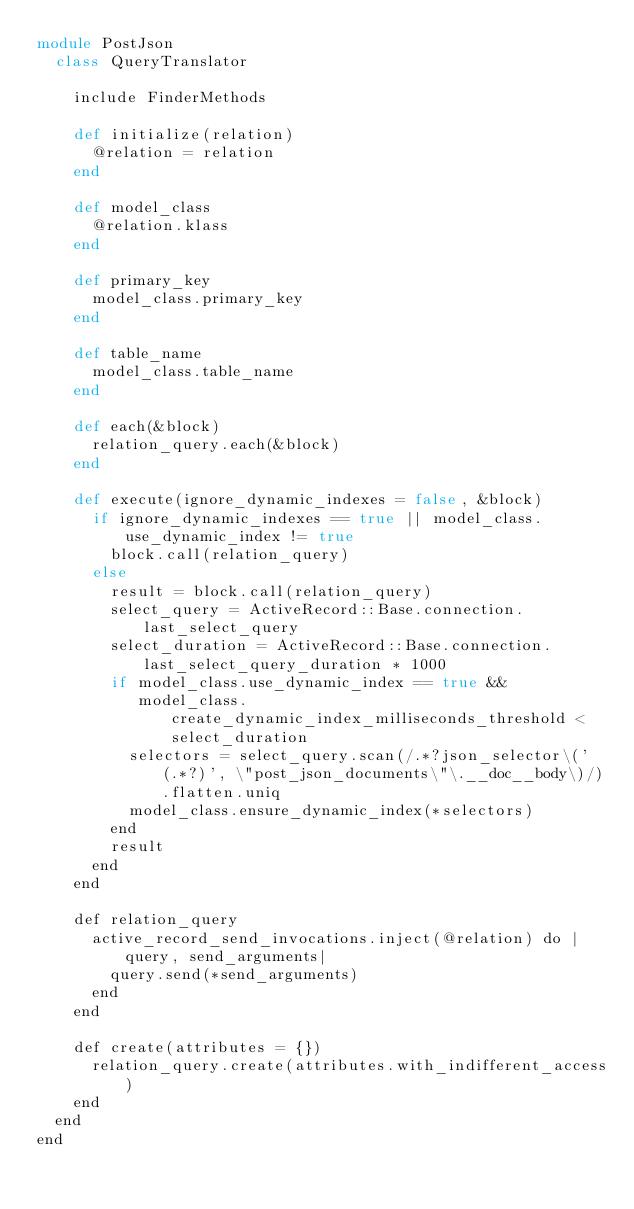<code> <loc_0><loc_0><loc_500><loc_500><_Ruby_>module PostJson
  class QueryTranslator

    include FinderMethods

    def initialize(relation)
      @relation = relation
    end

    def model_class
      @relation.klass
    end

    def primary_key
      model_class.primary_key
    end

    def table_name
      model_class.table_name
    end

    def each(&block)
      relation_query.each(&block)
    end

    def execute(ignore_dynamic_indexes = false, &block)
      if ignore_dynamic_indexes == true || model_class.use_dynamic_index != true
        block.call(relation_query)
      else
        result = block.call(relation_query)
        select_query = ActiveRecord::Base.connection.last_select_query
        select_duration = ActiveRecord::Base.connection.last_select_query_duration * 1000
        if model_class.use_dynamic_index == true &&
           model_class.create_dynamic_index_milliseconds_threshold < select_duration
          selectors = select_query.scan(/.*?json_selector\('(.*?)', \"post_json_documents\"\.__doc__body\)/).flatten.uniq
          model_class.ensure_dynamic_index(*selectors)
        end
        result
      end
    end

    def relation_query
      active_record_send_invocations.inject(@relation) do |query, send_arguments|
        query.send(*send_arguments)
      end
    end

    def create(attributes = {})
      relation_query.create(attributes.with_indifferent_access)
    end
  end
end</code> 